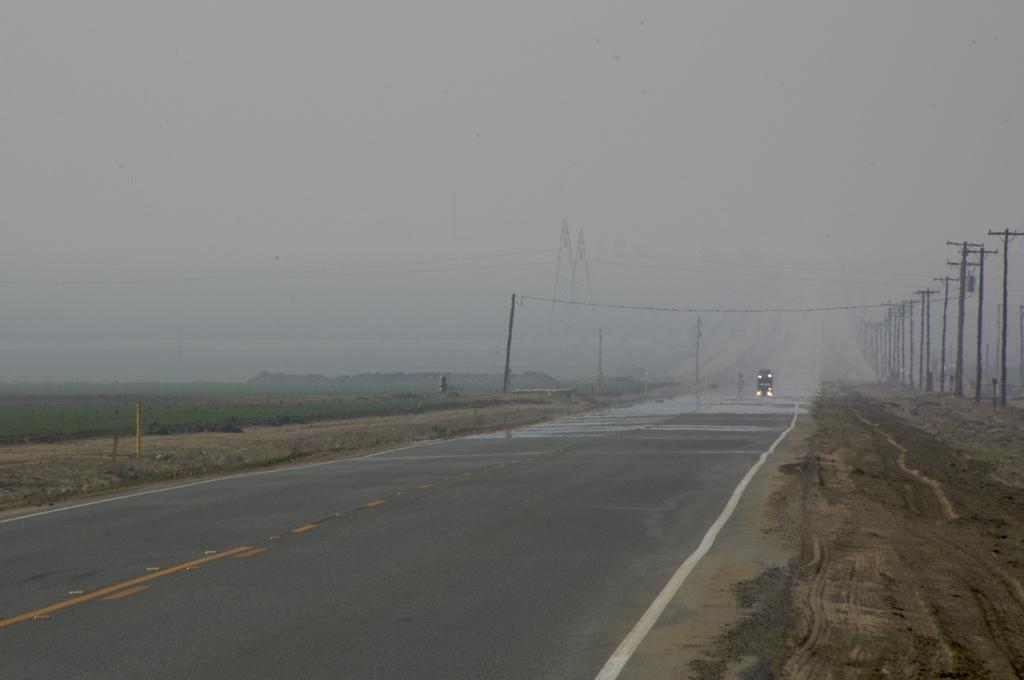Could you give a brief overview of what you see in this image? In this image we can see a vehicle on the road. On the left side of the image, we can see land, pole and grass. On the right side of the image, we can see poles and wires. At the top of the image, we can see the sky. 